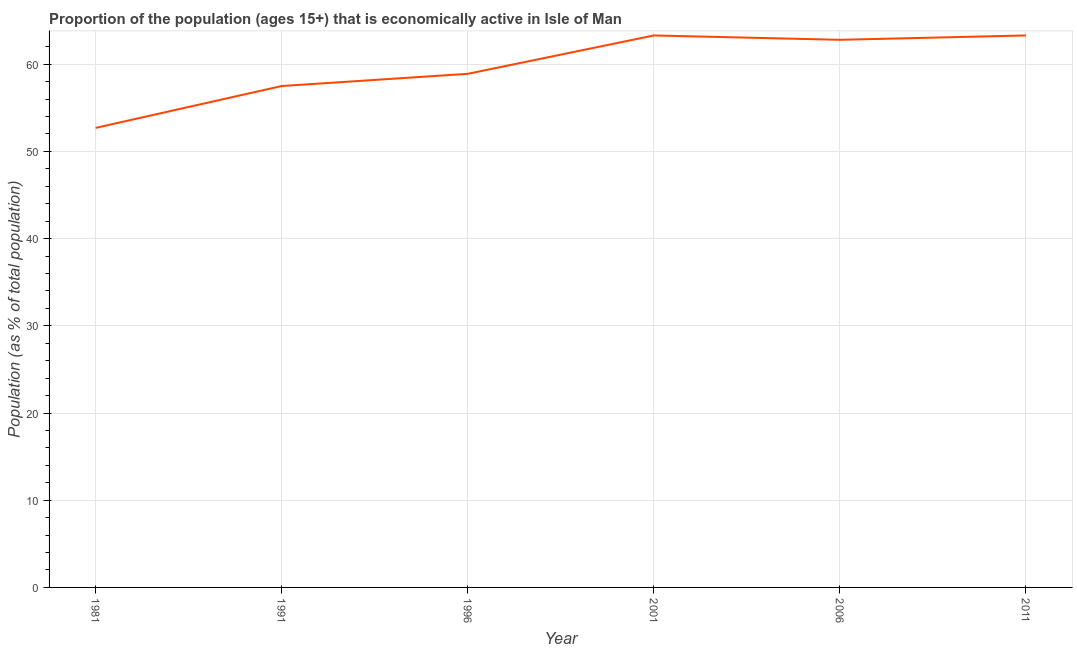What is the percentage of economically active population in 2001?
Ensure brevity in your answer.  63.3. Across all years, what is the maximum percentage of economically active population?
Give a very brief answer. 63.3. Across all years, what is the minimum percentage of economically active population?
Offer a terse response. 52.7. In which year was the percentage of economically active population maximum?
Offer a terse response. 2001. What is the sum of the percentage of economically active population?
Make the answer very short. 358.5. What is the difference between the percentage of economically active population in 1996 and 2001?
Your answer should be very brief. -4.4. What is the average percentage of economically active population per year?
Offer a terse response. 59.75. What is the median percentage of economically active population?
Make the answer very short. 60.85. Do a majority of the years between 2001 and 1981 (inclusive) have percentage of economically active population greater than 56 %?
Offer a very short reply. Yes. What is the ratio of the percentage of economically active population in 1981 to that in 1996?
Your answer should be very brief. 0.89. Is the percentage of economically active population in 1981 less than that in 2006?
Provide a succinct answer. Yes. Is the difference between the percentage of economically active population in 1996 and 2006 greater than the difference between any two years?
Offer a very short reply. No. Is the sum of the percentage of economically active population in 1981 and 1991 greater than the maximum percentage of economically active population across all years?
Offer a terse response. Yes. What is the difference between the highest and the lowest percentage of economically active population?
Provide a short and direct response. 10.6. Does the graph contain any zero values?
Provide a short and direct response. No. What is the title of the graph?
Give a very brief answer. Proportion of the population (ages 15+) that is economically active in Isle of Man. What is the label or title of the X-axis?
Offer a terse response. Year. What is the label or title of the Y-axis?
Give a very brief answer. Population (as % of total population). What is the Population (as % of total population) in 1981?
Your answer should be compact. 52.7. What is the Population (as % of total population) in 1991?
Your answer should be compact. 57.5. What is the Population (as % of total population) in 1996?
Ensure brevity in your answer.  58.9. What is the Population (as % of total population) in 2001?
Provide a succinct answer. 63.3. What is the Population (as % of total population) in 2006?
Ensure brevity in your answer.  62.8. What is the Population (as % of total population) in 2011?
Keep it short and to the point. 63.3. What is the difference between the Population (as % of total population) in 1981 and 1991?
Make the answer very short. -4.8. What is the difference between the Population (as % of total population) in 1981 and 2001?
Keep it short and to the point. -10.6. What is the difference between the Population (as % of total population) in 1991 and 2001?
Give a very brief answer. -5.8. What is the difference between the Population (as % of total population) in 1996 and 2006?
Provide a short and direct response. -3.9. What is the difference between the Population (as % of total population) in 2001 and 2006?
Ensure brevity in your answer.  0.5. What is the difference between the Population (as % of total population) in 2001 and 2011?
Your answer should be very brief. 0. What is the difference between the Population (as % of total population) in 2006 and 2011?
Offer a very short reply. -0.5. What is the ratio of the Population (as % of total population) in 1981 to that in 1991?
Make the answer very short. 0.92. What is the ratio of the Population (as % of total population) in 1981 to that in 1996?
Your response must be concise. 0.9. What is the ratio of the Population (as % of total population) in 1981 to that in 2001?
Give a very brief answer. 0.83. What is the ratio of the Population (as % of total population) in 1981 to that in 2006?
Your answer should be compact. 0.84. What is the ratio of the Population (as % of total population) in 1981 to that in 2011?
Keep it short and to the point. 0.83. What is the ratio of the Population (as % of total population) in 1991 to that in 1996?
Make the answer very short. 0.98. What is the ratio of the Population (as % of total population) in 1991 to that in 2001?
Offer a very short reply. 0.91. What is the ratio of the Population (as % of total population) in 1991 to that in 2006?
Your answer should be very brief. 0.92. What is the ratio of the Population (as % of total population) in 1991 to that in 2011?
Offer a very short reply. 0.91. What is the ratio of the Population (as % of total population) in 1996 to that in 2001?
Keep it short and to the point. 0.93. What is the ratio of the Population (as % of total population) in 1996 to that in 2006?
Offer a very short reply. 0.94. What is the ratio of the Population (as % of total population) in 1996 to that in 2011?
Offer a terse response. 0.93. What is the ratio of the Population (as % of total population) in 2006 to that in 2011?
Keep it short and to the point. 0.99. 